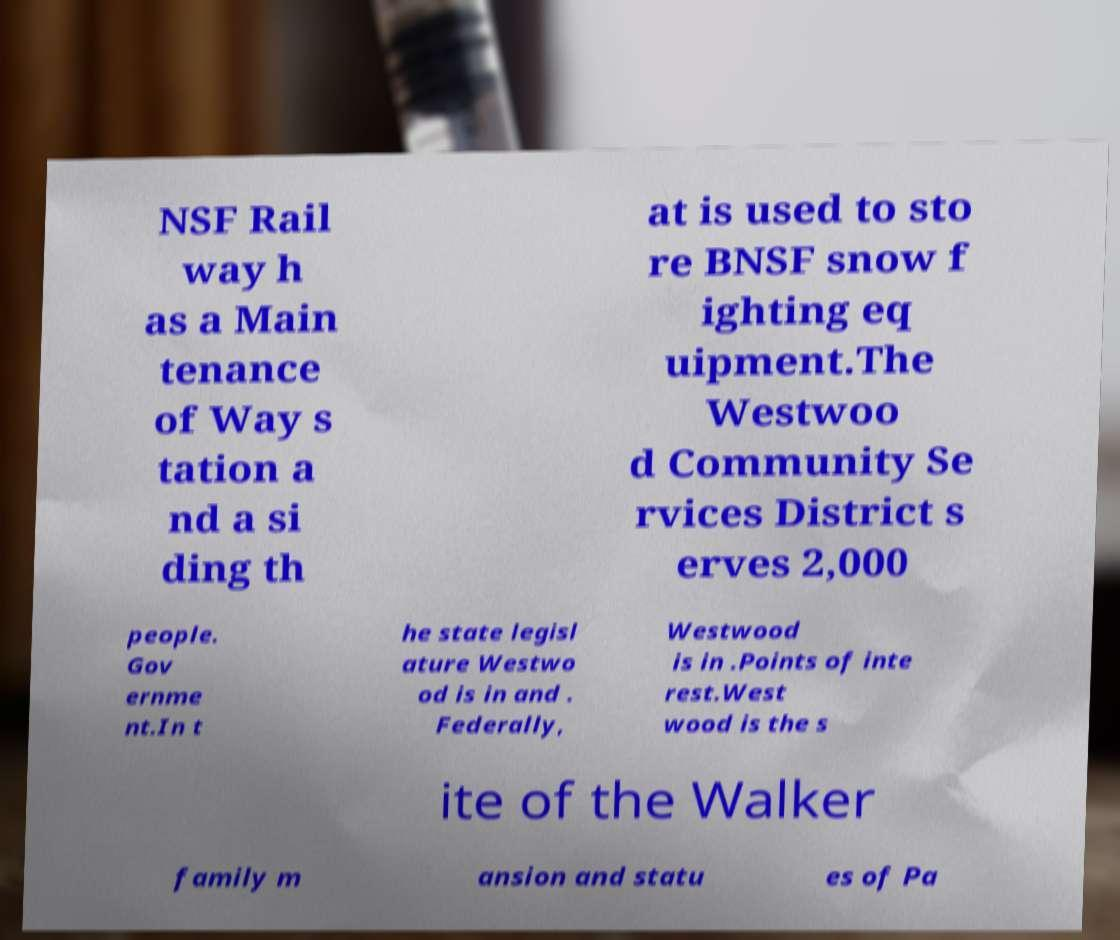Could you extract and type out the text from this image? NSF Rail way h as a Main tenance of Way s tation a nd a si ding th at is used to sto re BNSF snow f ighting eq uipment.The Westwoo d Community Se rvices District s erves 2,000 people. Gov ernme nt.In t he state legisl ature Westwo od is in and . Federally, Westwood is in .Points of inte rest.West wood is the s ite of the Walker family m ansion and statu es of Pa 